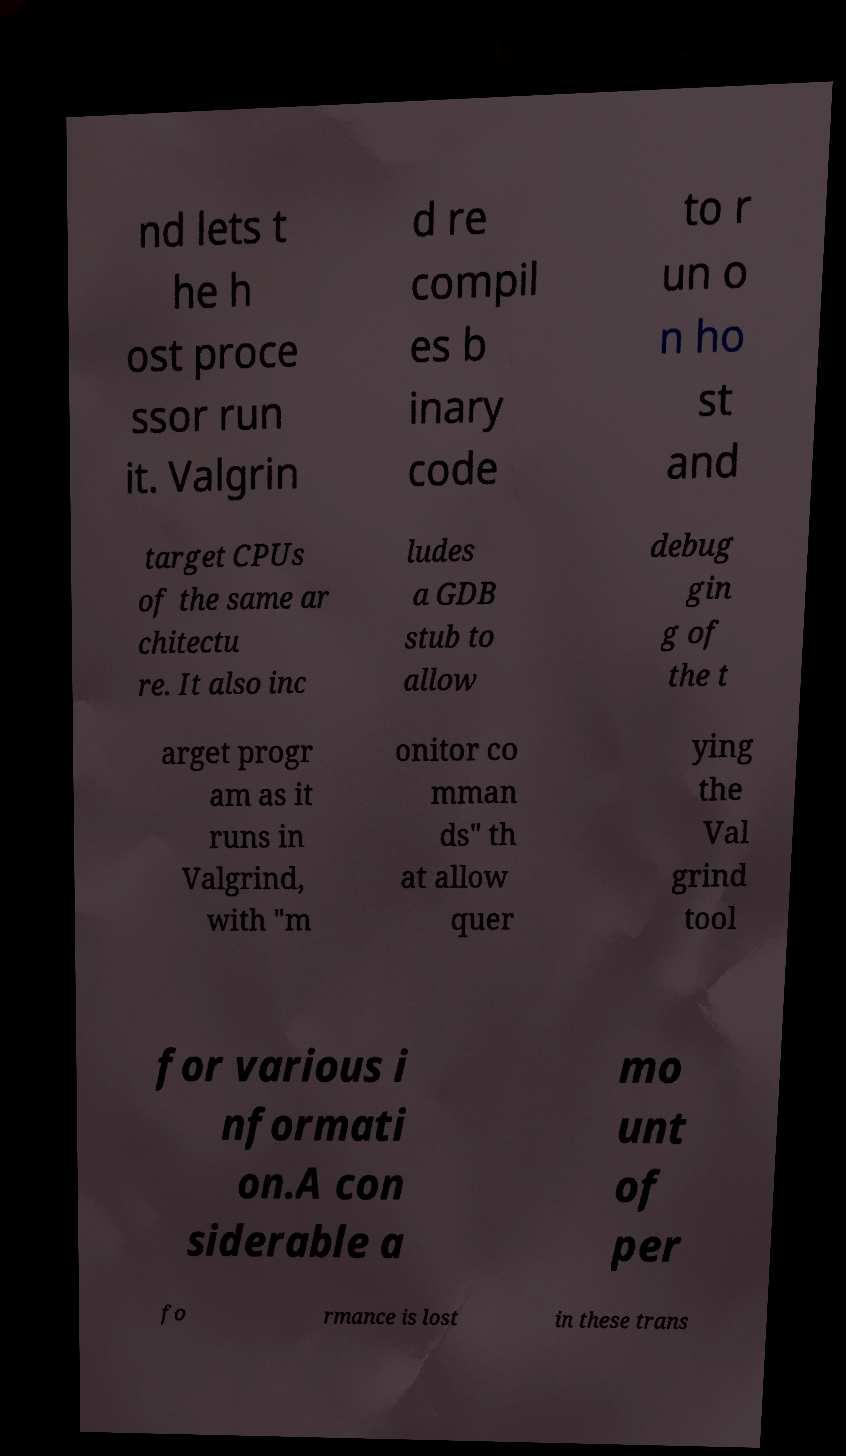Please identify and transcribe the text found in this image. nd lets t he h ost proce ssor run it. Valgrin d re compil es b inary code to r un o n ho st and target CPUs of the same ar chitectu re. It also inc ludes a GDB stub to allow debug gin g of the t arget progr am as it runs in Valgrind, with "m onitor co mman ds" th at allow quer ying the Val grind tool for various i nformati on.A con siderable a mo unt of per fo rmance is lost in these trans 